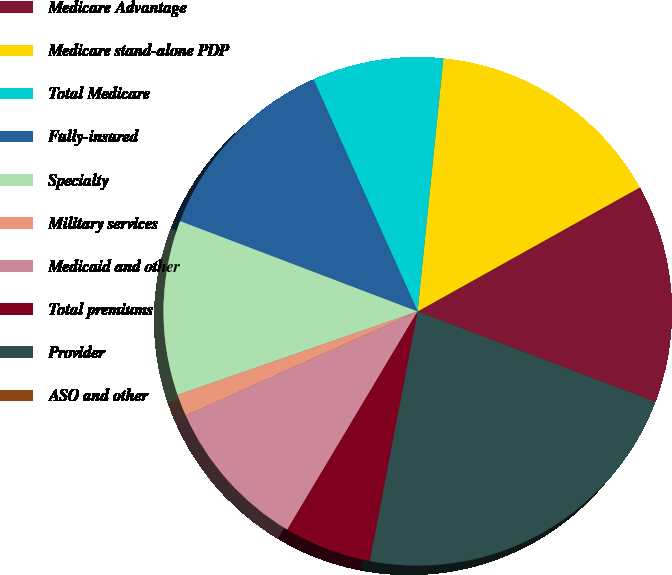Convert chart to OTSL. <chart><loc_0><loc_0><loc_500><loc_500><pie_chart><fcel>Medicare Advantage<fcel>Medicare stand-alone PDP<fcel>Total Medicare<fcel>Fully-insured<fcel>Specialty<fcel>Military services<fcel>Medicaid and other<fcel>Total premiums<fcel>Provider<fcel>ASO and other<nl><fcel>13.89%<fcel>15.28%<fcel>8.33%<fcel>12.5%<fcel>11.11%<fcel>1.39%<fcel>9.72%<fcel>5.56%<fcel>22.22%<fcel>0.0%<nl></chart> 